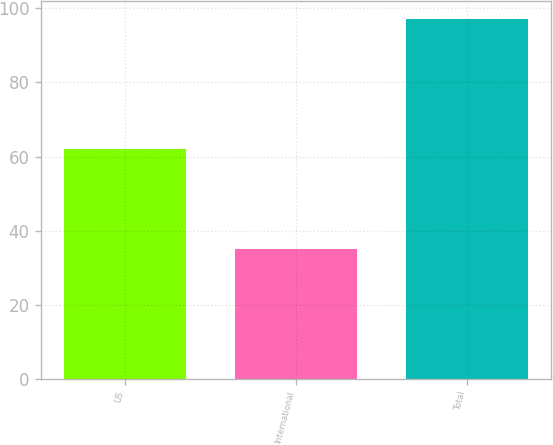<chart> <loc_0><loc_0><loc_500><loc_500><bar_chart><fcel>US<fcel>International<fcel>Total<nl><fcel>62<fcel>35<fcel>97<nl></chart> 